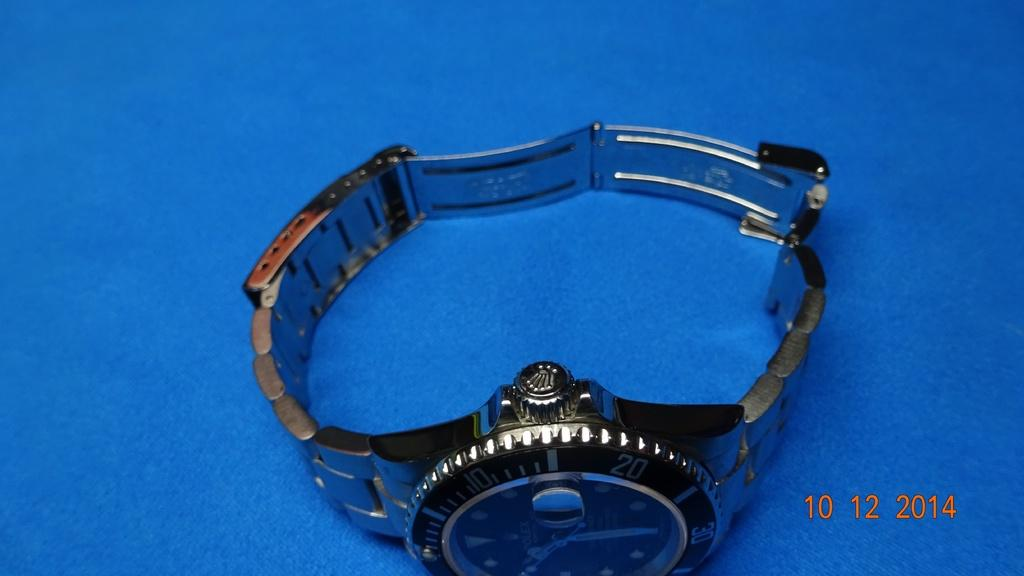<image>
Summarize the visual content of the image. Silver wrist watch which has the number 20 and 10 on it. 